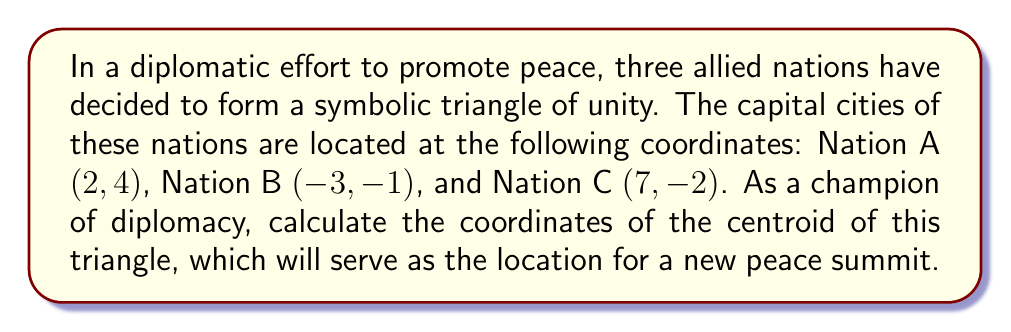Can you answer this question? To find the centroid of a triangle, we need to follow these steps:

1) The centroid of a triangle is located at the arithmetic mean of the coordinates of its vertices. Let's denote the x-coordinate of the centroid as $x_c$ and the y-coordinate as $y_c$.

2) For the x-coordinate:
   $$x_c = \frac{x_A + x_B + x_C}{3}$$
   where $x_A$, $x_B$, and $x_C$ are the x-coordinates of Nations A, B, and C respectively.

3) Substituting the values:
   $$x_c = \frac{2 + (-3) + 7}{3} = \frac{6}{3} = 2$$

4) For the y-coordinate:
   $$y_c = \frac{y_A + y_B + y_C}{3}$$
   where $y_A$, $y_B$, and $y_C$ are the y-coordinates of Nations A, B, and C respectively.

5) Substituting the values:
   $$y_c = \frac{4 + (-1) + (-2)}{3} = \frac{1}{3}$$

6) Therefore, the coordinates of the centroid are $(2, \frac{1}{3})$.

[asy]
unitsize(1cm);
pair A = (2,4);
pair B = (-3,-1);
pair C = (7,-2);
pair centroid = (2,1/3);

draw(A--B--C--cycle);
dot(A);
dot(B);
dot(C);
dot(centroid,red);

label("A (2, 4)", A, N);
label("B (-3, -1)", B, SW);
label("C (7, -2)", C, SE);
label("Centroid (2, 1/3)", centroid, E);
[/asy]
Answer: $(2, \frac{1}{3})$ 